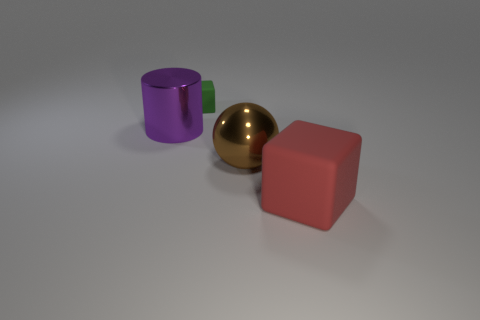There is a red thing; what shape is it?
Ensure brevity in your answer.  Cube. What material is the cube behind the matte cube right of the object that is behind the big metallic cylinder?
Your answer should be very brief. Rubber. How many brown objects are metal cylinders or large shiny spheres?
Offer a terse response. 1. There is a matte cube behind the large metallic thing behind the shiny object right of the large purple metallic thing; how big is it?
Ensure brevity in your answer.  Small. There is another rubber object that is the same shape as the red thing; what is its size?
Make the answer very short. Small. How many large objects are green blocks or yellow metallic cylinders?
Provide a succinct answer. 0. Is the material of the block in front of the small green rubber object the same as the block that is behind the red block?
Your answer should be compact. Yes. What material is the big thing in front of the large brown object?
Your answer should be compact. Rubber. What number of metallic things are purple cylinders or large blue spheres?
Your answer should be very brief. 1. What is the color of the rubber block that is behind the big thing to the left of the green matte object?
Provide a succinct answer. Green. 